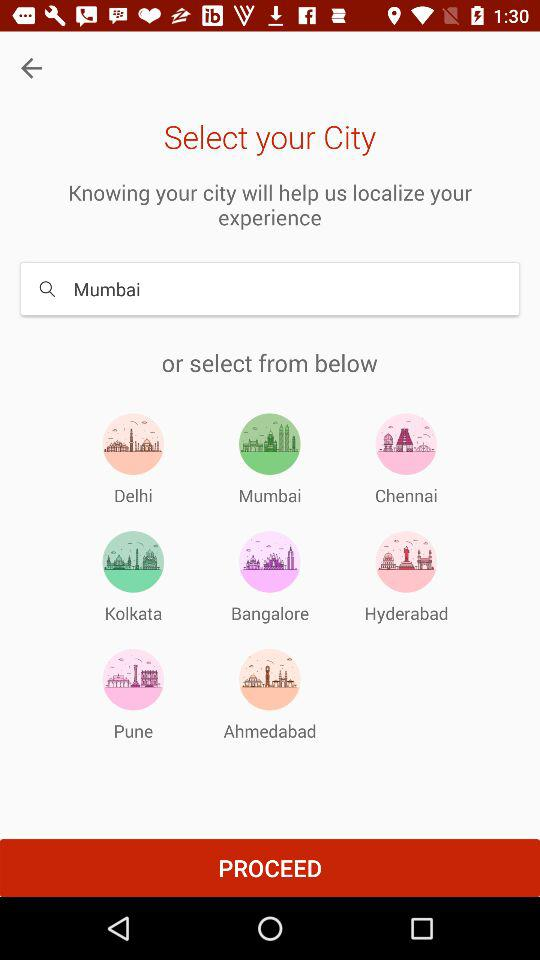Which city is entered? The entered city is Mumbai. 